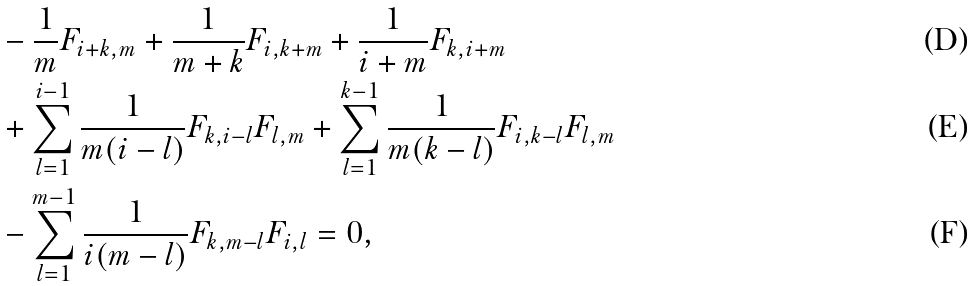Convert formula to latex. <formula><loc_0><loc_0><loc_500><loc_500>& - \frac { 1 } { m } F _ { i + k , m } + \frac { 1 } { m + k } F _ { i , k + m } + \frac { 1 } { i + m } F _ { k , i + m } \\ & + \sum _ { l = 1 } ^ { i - 1 } \frac { 1 } { m ( i - l ) } F _ { k , i - l } F _ { l , m } + \sum _ { l = 1 } ^ { k - 1 } \frac { 1 } { m ( k - l ) } F _ { i , k - l } F _ { l , m } \\ & - \sum _ { l = 1 } ^ { m - 1 } \frac { 1 } { i ( m - l ) } F _ { k , m - l } F _ { i , l } = 0 ,</formula> 